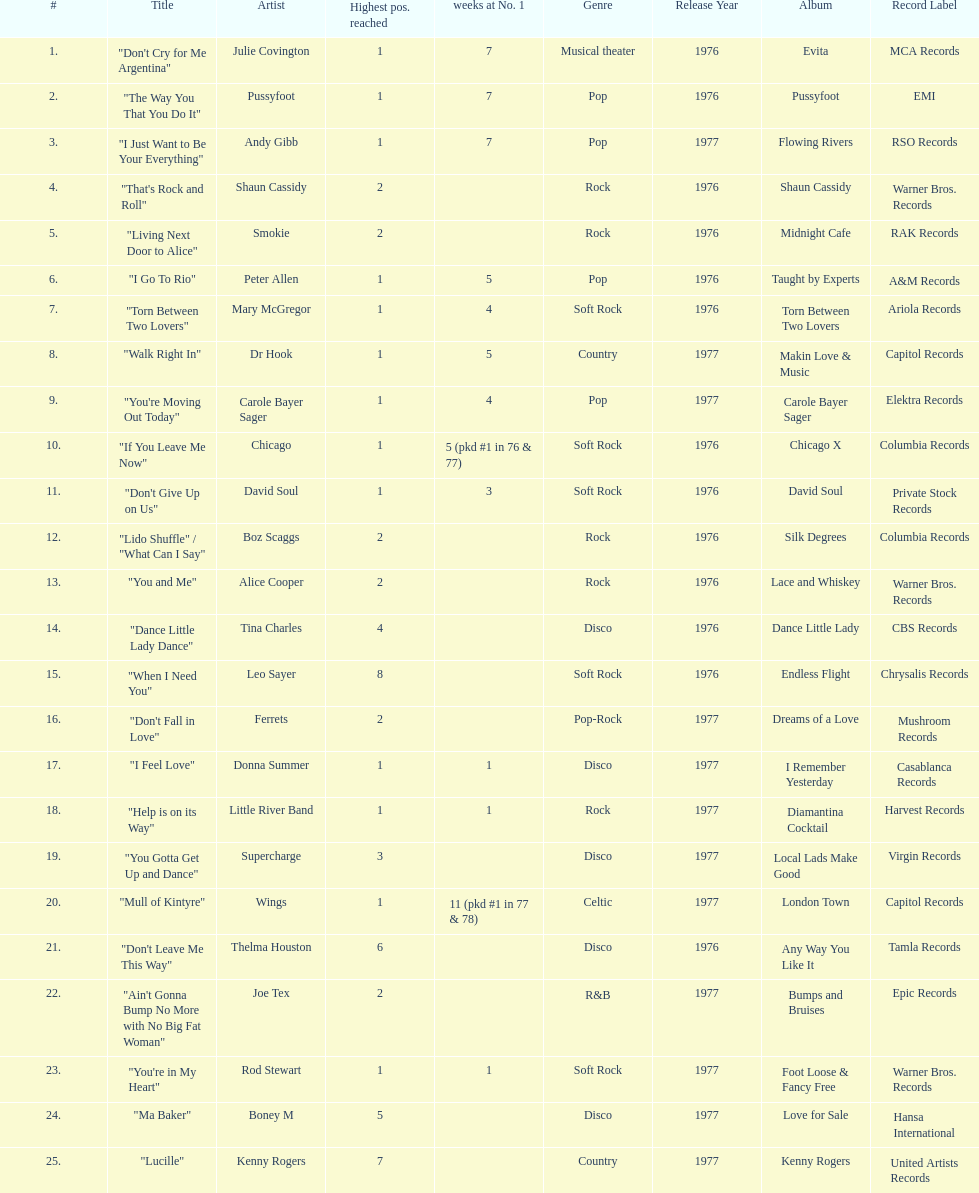Which three artists had a single at number 1 for at least 7 weeks on the australian singles charts in 1977? Julie Covington, Pussyfoot, Andy Gibb. 